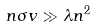Convert formula to latex. <formula><loc_0><loc_0><loc_500><loc_500>n \sigma v \gg \lambda n ^ { 2 }</formula> 